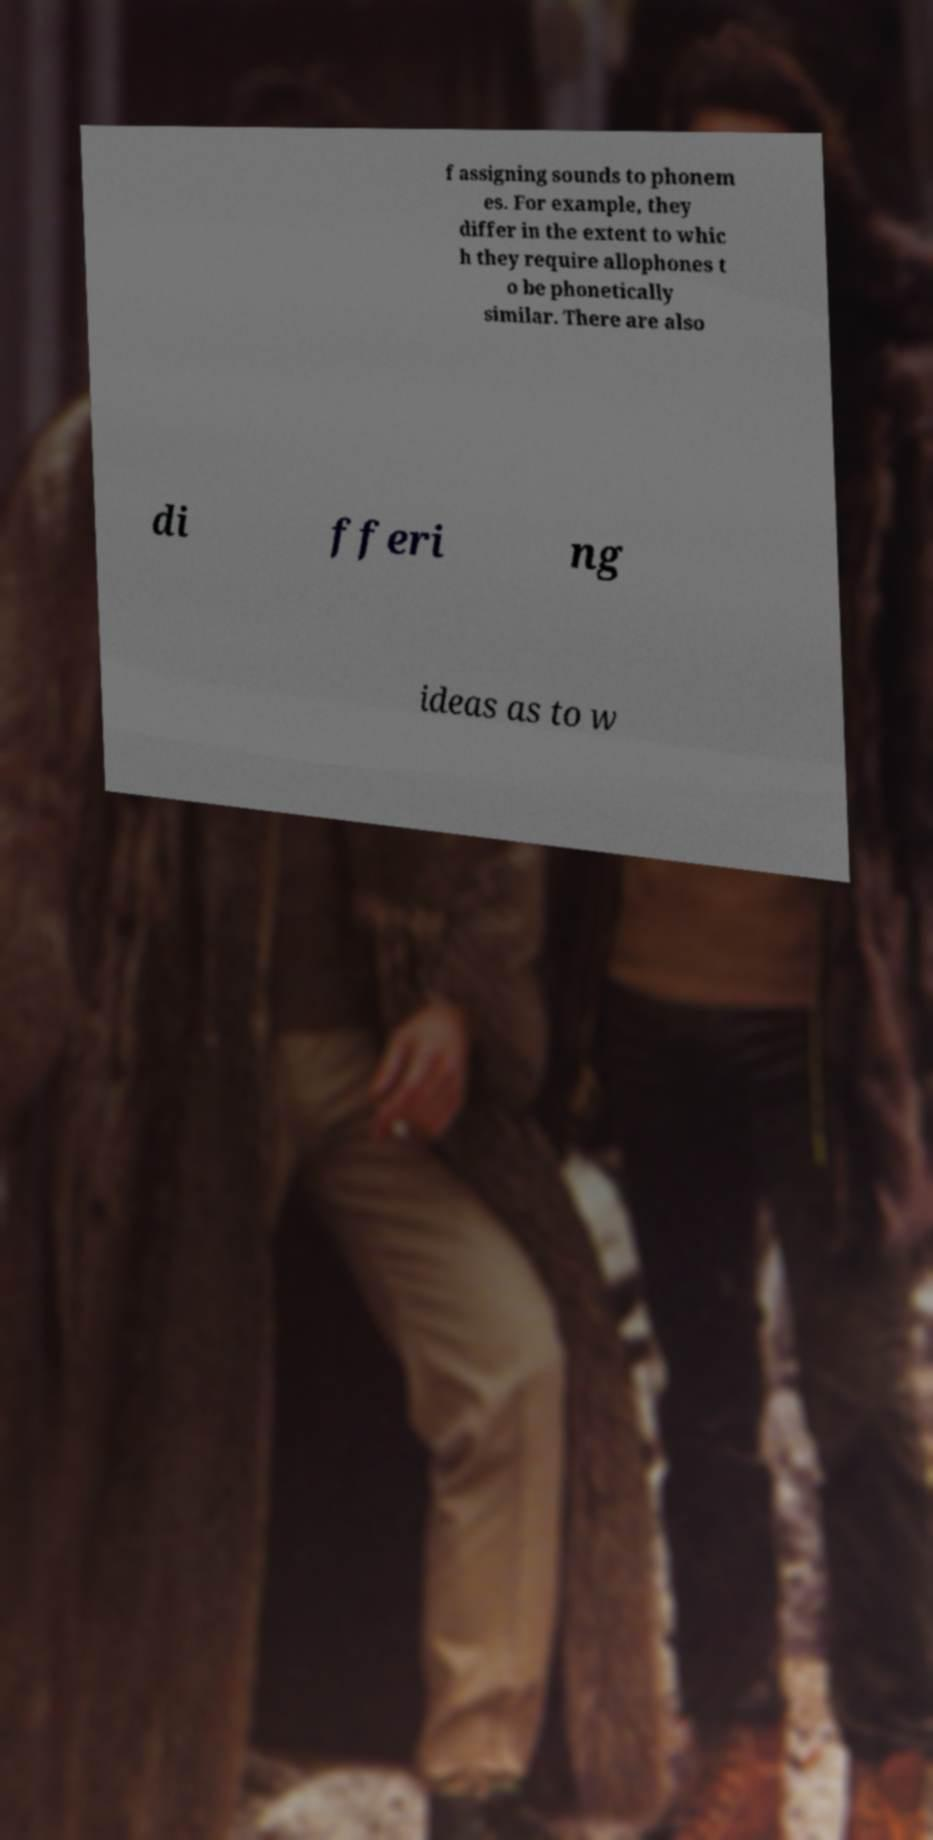Could you extract and type out the text from this image? f assigning sounds to phonem es. For example, they differ in the extent to whic h they require allophones t o be phonetically similar. There are also di fferi ng ideas as to w 